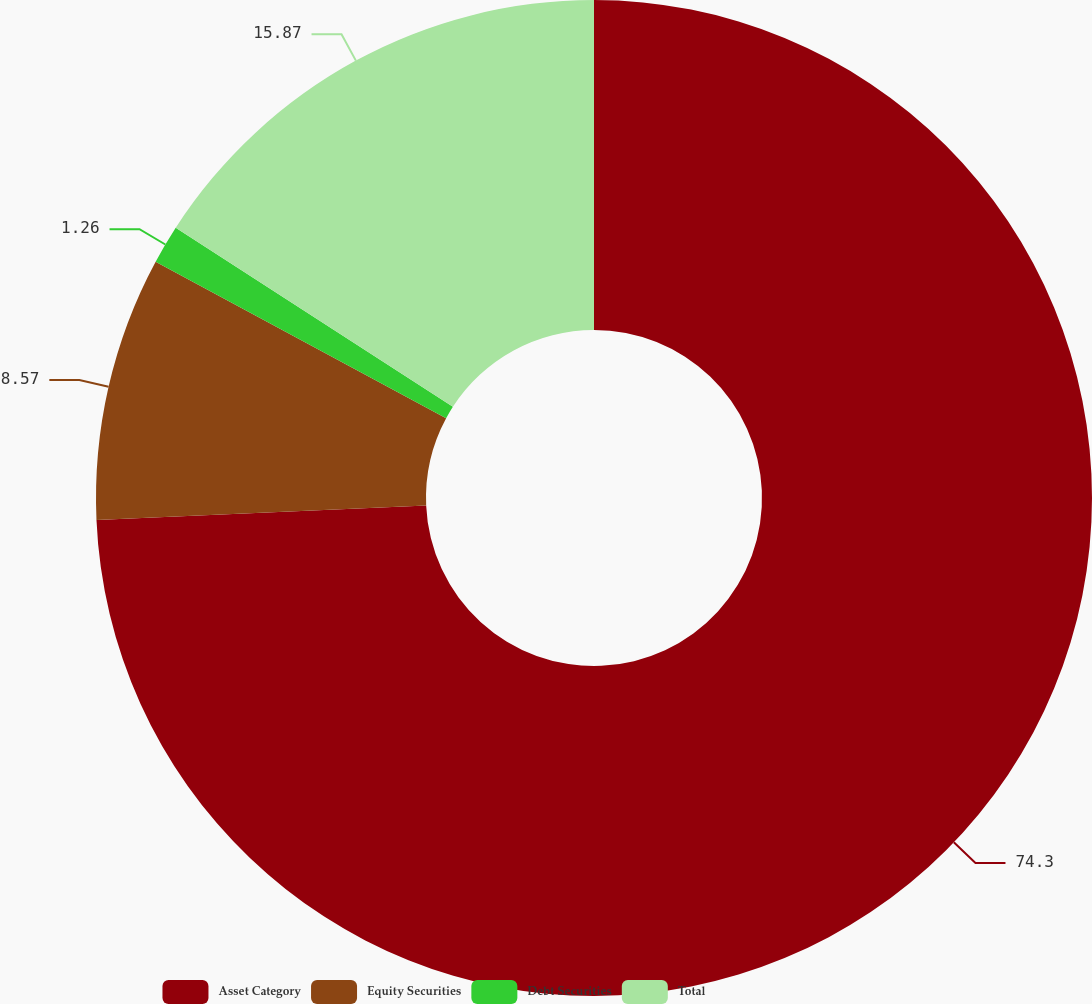<chart> <loc_0><loc_0><loc_500><loc_500><pie_chart><fcel>Asset Category<fcel>Equity Securities<fcel>Debt Securities<fcel>Total<nl><fcel>74.3%<fcel>8.57%<fcel>1.26%<fcel>15.87%<nl></chart> 